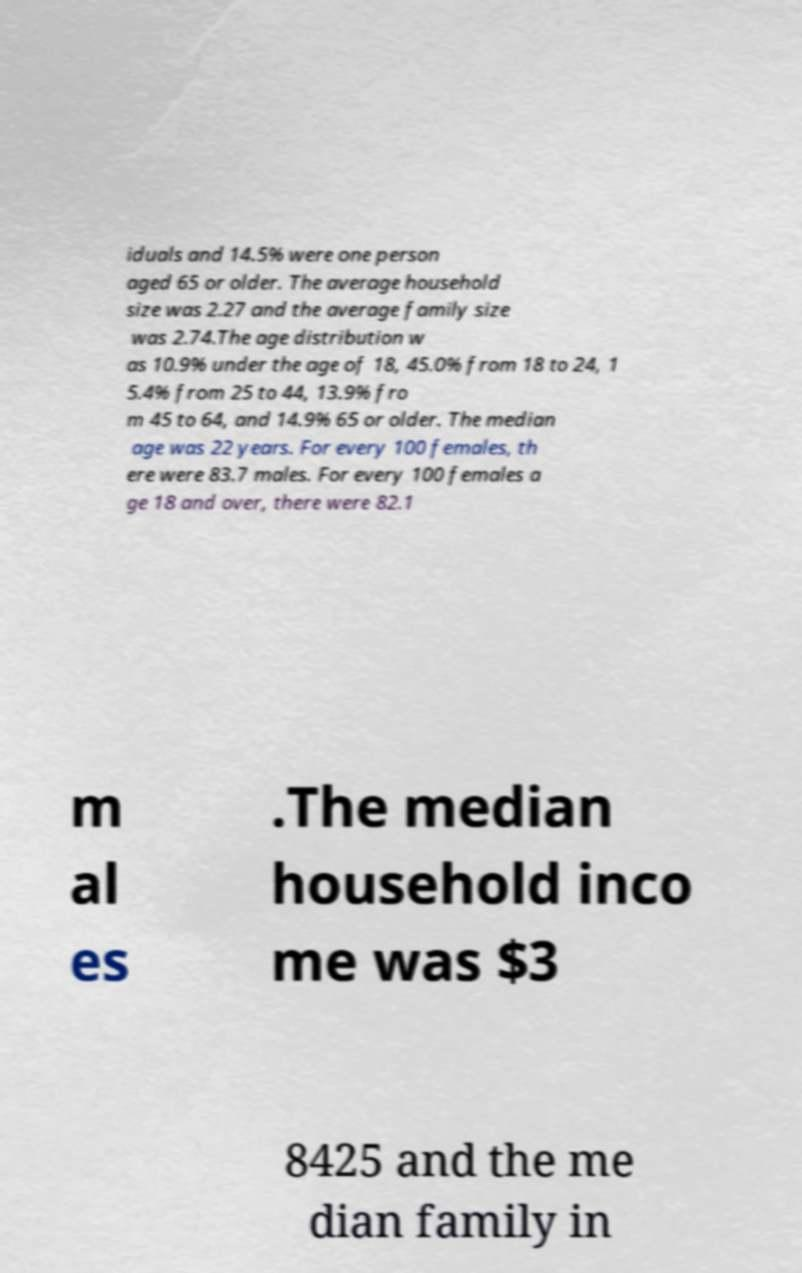Could you extract and type out the text from this image? iduals and 14.5% were one person aged 65 or older. The average household size was 2.27 and the average family size was 2.74.The age distribution w as 10.9% under the age of 18, 45.0% from 18 to 24, 1 5.4% from 25 to 44, 13.9% fro m 45 to 64, and 14.9% 65 or older. The median age was 22 years. For every 100 females, th ere were 83.7 males. For every 100 females a ge 18 and over, there were 82.1 m al es .The median household inco me was $3 8425 and the me dian family in 